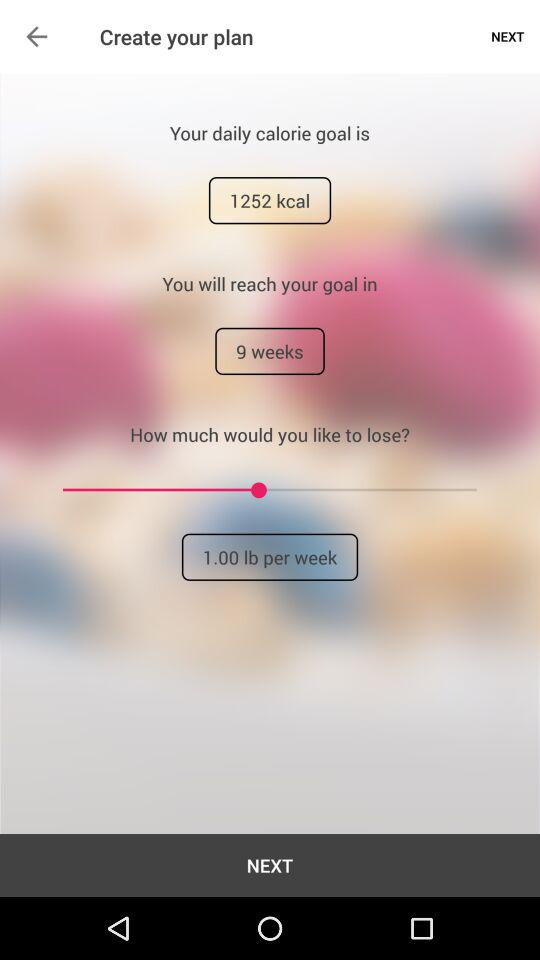What weight should they lose per week? They should lose 1 pound per week. 